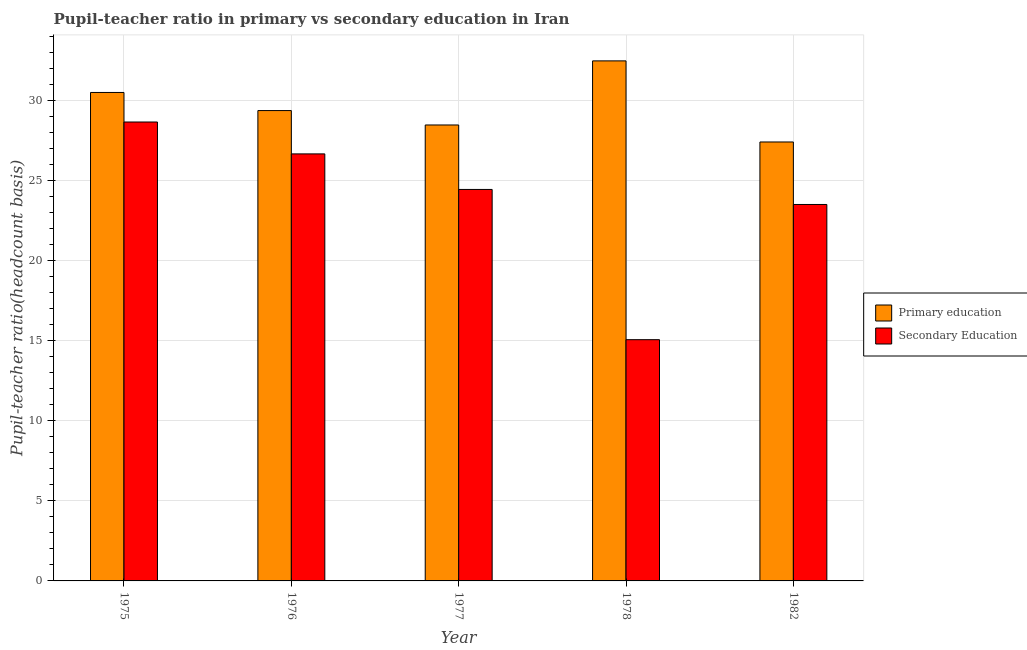How many different coloured bars are there?
Offer a terse response. 2. Are the number of bars per tick equal to the number of legend labels?
Your response must be concise. Yes. Are the number of bars on each tick of the X-axis equal?
Give a very brief answer. Yes. What is the label of the 4th group of bars from the left?
Your answer should be compact. 1978. What is the pupil teacher ratio on secondary education in 1976?
Ensure brevity in your answer.  26.67. Across all years, what is the maximum pupil-teacher ratio in primary education?
Offer a terse response. 32.48. Across all years, what is the minimum pupil-teacher ratio in primary education?
Offer a very short reply. 27.41. In which year was the pupil-teacher ratio in primary education maximum?
Provide a short and direct response. 1978. What is the total pupil-teacher ratio in primary education in the graph?
Give a very brief answer. 148.26. What is the difference between the pupil teacher ratio on secondary education in 1975 and that in 1977?
Your answer should be very brief. 4.21. What is the difference between the pupil teacher ratio on secondary education in 1978 and the pupil-teacher ratio in primary education in 1977?
Your answer should be compact. -9.38. What is the average pupil teacher ratio on secondary education per year?
Ensure brevity in your answer.  23.67. In the year 1976, what is the difference between the pupil-teacher ratio in primary education and pupil teacher ratio on secondary education?
Provide a succinct answer. 0. In how many years, is the pupil teacher ratio on secondary education greater than 11?
Offer a very short reply. 5. What is the ratio of the pupil-teacher ratio in primary education in 1977 to that in 1982?
Offer a terse response. 1.04. Is the pupil teacher ratio on secondary education in 1976 less than that in 1982?
Offer a terse response. No. What is the difference between the highest and the second highest pupil teacher ratio on secondary education?
Your answer should be compact. 1.99. What is the difference between the highest and the lowest pupil teacher ratio on secondary education?
Your answer should be very brief. 13.59. What does the 2nd bar from the left in 1977 represents?
Ensure brevity in your answer.  Secondary Education. How many bars are there?
Your answer should be very brief. 10. What is the difference between two consecutive major ticks on the Y-axis?
Your response must be concise. 5. Are the values on the major ticks of Y-axis written in scientific E-notation?
Provide a short and direct response. No. Does the graph contain any zero values?
Give a very brief answer. No. Does the graph contain grids?
Provide a succinct answer. Yes. Where does the legend appear in the graph?
Offer a very short reply. Center right. How many legend labels are there?
Your answer should be compact. 2. How are the legend labels stacked?
Make the answer very short. Vertical. What is the title of the graph?
Your response must be concise. Pupil-teacher ratio in primary vs secondary education in Iran. Does "Secondary school" appear as one of the legend labels in the graph?
Offer a very short reply. No. What is the label or title of the Y-axis?
Your answer should be very brief. Pupil-teacher ratio(headcount basis). What is the Pupil-teacher ratio(headcount basis) of Primary education in 1975?
Make the answer very short. 30.51. What is the Pupil-teacher ratio(headcount basis) in Secondary Education in 1975?
Keep it short and to the point. 28.66. What is the Pupil-teacher ratio(headcount basis) in Primary education in 1976?
Offer a very short reply. 29.38. What is the Pupil-teacher ratio(headcount basis) of Secondary Education in 1976?
Provide a succinct answer. 26.67. What is the Pupil-teacher ratio(headcount basis) in Primary education in 1977?
Keep it short and to the point. 28.48. What is the Pupil-teacher ratio(headcount basis) in Secondary Education in 1977?
Your response must be concise. 24.45. What is the Pupil-teacher ratio(headcount basis) in Primary education in 1978?
Offer a very short reply. 32.48. What is the Pupil-teacher ratio(headcount basis) of Secondary Education in 1978?
Ensure brevity in your answer.  15.07. What is the Pupil-teacher ratio(headcount basis) of Primary education in 1982?
Your response must be concise. 27.41. What is the Pupil-teacher ratio(headcount basis) of Secondary Education in 1982?
Offer a terse response. 23.51. Across all years, what is the maximum Pupil-teacher ratio(headcount basis) of Primary education?
Offer a very short reply. 32.48. Across all years, what is the maximum Pupil-teacher ratio(headcount basis) of Secondary Education?
Offer a terse response. 28.66. Across all years, what is the minimum Pupil-teacher ratio(headcount basis) of Primary education?
Keep it short and to the point. 27.41. Across all years, what is the minimum Pupil-teacher ratio(headcount basis) of Secondary Education?
Provide a succinct answer. 15.07. What is the total Pupil-teacher ratio(headcount basis) of Primary education in the graph?
Make the answer very short. 148.26. What is the total Pupil-teacher ratio(headcount basis) in Secondary Education in the graph?
Keep it short and to the point. 118.36. What is the difference between the Pupil-teacher ratio(headcount basis) in Primary education in 1975 and that in 1976?
Give a very brief answer. 1.13. What is the difference between the Pupil-teacher ratio(headcount basis) of Secondary Education in 1975 and that in 1976?
Give a very brief answer. 1.99. What is the difference between the Pupil-teacher ratio(headcount basis) in Primary education in 1975 and that in 1977?
Your response must be concise. 2.03. What is the difference between the Pupil-teacher ratio(headcount basis) of Secondary Education in 1975 and that in 1977?
Give a very brief answer. 4.21. What is the difference between the Pupil-teacher ratio(headcount basis) of Primary education in 1975 and that in 1978?
Ensure brevity in your answer.  -1.97. What is the difference between the Pupil-teacher ratio(headcount basis) in Secondary Education in 1975 and that in 1978?
Make the answer very short. 13.6. What is the difference between the Pupil-teacher ratio(headcount basis) in Primary education in 1975 and that in 1982?
Ensure brevity in your answer.  3.09. What is the difference between the Pupil-teacher ratio(headcount basis) of Secondary Education in 1975 and that in 1982?
Offer a very short reply. 5.15. What is the difference between the Pupil-teacher ratio(headcount basis) of Primary education in 1976 and that in 1977?
Ensure brevity in your answer.  0.9. What is the difference between the Pupil-teacher ratio(headcount basis) of Secondary Education in 1976 and that in 1977?
Offer a very short reply. 2.22. What is the difference between the Pupil-teacher ratio(headcount basis) of Primary education in 1976 and that in 1978?
Provide a short and direct response. -3.1. What is the difference between the Pupil-teacher ratio(headcount basis) in Secondary Education in 1976 and that in 1978?
Provide a succinct answer. 11.6. What is the difference between the Pupil-teacher ratio(headcount basis) of Primary education in 1976 and that in 1982?
Offer a very short reply. 1.96. What is the difference between the Pupil-teacher ratio(headcount basis) of Secondary Education in 1976 and that in 1982?
Your answer should be very brief. 3.16. What is the difference between the Pupil-teacher ratio(headcount basis) in Primary education in 1977 and that in 1978?
Provide a succinct answer. -4. What is the difference between the Pupil-teacher ratio(headcount basis) in Secondary Education in 1977 and that in 1978?
Ensure brevity in your answer.  9.38. What is the difference between the Pupil-teacher ratio(headcount basis) in Primary education in 1977 and that in 1982?
Keep it short and to the point. 1.06. What is the difference between the Pupil-teacher ratio(headcount basis) of Secondary Education in 1977 and that in 1982?
Ensure brevity in your answer.  0.94. What is the difference between the Pupil-teacher ratio(headcount basis) in Primary education in 1978 and that in 1982?
Offer a terse response. 5.07. What is the difference between the Pupil-teacher ratio(headcount basis) of Secondary Education in 1978 and that in 1982?
Give a very brief answer. -8.44. What is the difference between the Pupil-teacher ratio(headcount basis) of Primary education in 1975 and the Pupil-teacher ratio(headcount basis) of Secondary Education in 1976?
Give a very brief answer. 3.84. What is the difference between the Pupil-teacher ratio(headcount basis) of Primary education in 1975 and the Pupil-teacher ratio(headcount basis) of Secondary Education in 1977?
Give a very brief answer. 6.06. What is the difference between the Pupil-teacher ratio(headcount basis) in Primary education in 1975 and the Pupil-teacher ratio(headcount basis) in Secondary Education in 1978?
Your answer should be very brief. 15.44. What is the difference between the Pupil-teacher ratio(headcount basis) of Primary education in 1975 and the Pupil-teacher ratio(headcount basis) of Secondary Education in 1982?
Your answer should be very brief. 7. What is the difference between the Pupil-teacher ratio(headcount basis) in Primary education in 1976 and the Pupil-teacher ratio(headcount basis) in Secondary Education in 1977?
Your answer should be compact. 4.93. What is the difference between the Pupil-teacher ratio(headcount basis) in Primary education in 1976 and the Pupil-teacher ratio(headcount basis) in Secondary Education in 1978?
Your response must be concise. 14.31. What is the difference between the Pupil-teacher ratio(headcount basis) in Primary education in 1976 and the Pupil-teacher ratio(headcount basis) in Secondary Education in 1982?
Keep it short and to the point. 5.87. What is the difference between the Pupil-teacher ratio(headcount basis) of Primary education in 1977 and the Pupil-teacher ratio(headcount basis) of Secondary Education in 1978?
Your response must be concise. 13.41. What is the difference between the Pupil-teacher ratio(headcount basis) of Primary education in 1977 and the Pupil-teacher ratio(headcount basis) of Secondary Education in 1982?
Your response must be concise. 4.97. What is the difference between the Pupil-teacher ratio(headcount basis) in Primary education in 1978 and the Pupil-teacher ratio(headcount basis) in Secondary Education in 1982?
Offer a very short reply. 8.97. What is the average Pupil-teacher ratio(headcount basis) in Primary education per year?
Ensure brevity in your answer.  29.65. What is the average Pupil-teacher ratio(headcount basis) of Secondary Education per year?
Your answer should be compact. 23.67. In the year 1975, what is the difference between the Pupil-teacher ratio(headcount basis) of Primary education and Pupil-teacher ratio(headcount basis) of Secondary Education?
Keep it short and to the point. 1.85. In the year 1976, what is the difference between the Pupil-teacher ratio(headcount basis) of Primary education and Pupil-teacher ratio(headcount basis) of Secondary Education?
Ensure brevity in your answer.  2.71. In the year 1977, what is the difference between the Pupil-teacher ratio(headcount basis) of Primary education and Pupil-teacher ratio(headcount basis) of Secondary Education?
Provide a succinct answer. 4.03. In the year 1978, what is the difference between the Pupil-teacher ratio(headcount basis) of Primary education and Pupil-teacher ratio(headcount basis) of Secondary Education?
Offer a terse response. 17.41. In the year 1982, what is the difference between the Pupil-teacher ratio(headcount basis) in Primary education and Pupil-teacher ratio(headcount basis) in Secondary Education?
Provide a short and direct response. 3.9. What is the ratio of the Pupil-teacher ratio(headcount basis) of Primary education in 1975 to that in 1976?
Make the answer very short. 1.04. What is the ratio of the Pupil-teacher ratio(headcount basis) in Secondary Education in 1975 to that in 1976?
Ensure brevity in your answer.  1.07. What is the ratio of the Pupil-teacher ratio(headcount basis) in Primary education in 1975 to that in 1977?
Give a very brief answer. 1.07. What is the ratio of the Pupil-teacher ratio(headcount basis) in Secondary Education in 1975 to that in 1977?
Provide a short and direct response. 1.17. What is the ratio of the Pupil-teacher ratio(headcount basis) of Primary education in 1975 to that in 1978?
Make the answer very short. 0.94. What is the ratio of the Pupil-teacher ratio(headcount basis) of Secondary Education in 1975 to that in 1978?
Provide a short and direct response. 1.9. What is the ratio of the Pupil-teacher ratio(headcount basis) of Primary education in 1975 to that in 1982?
Offer a terse response. 1.11. What is the ratio of the Pupil-teacher ratio(headcount basis) in Secondary Education in 1975 to that in 1982?
Your answer should be compact. 1.22. What is the ratio of the Pupil-teacher ratio(headcount basis) of Primary education in 1976 to that in 1977?
Your response must be concise. 1.03. What is the ratio of the Pupil-teacher ratio(headcount basis) in Secondary Education in 1976 to that in 1977?
Give a very brief answer. 1.09. What is the ratio of the Pupil-teacher ratio(headcount basis) in Primary education in 1976 to that in 1978?
Give a very brief answer. 0.9. What is the ratio of the Pupil-teacher ratio(headcount basis) in Secondary Education in 1976 to that in 1978?
Offer a very short reply. 1.77. What is the ratio of the Pupil-teacher ratio(headcount basis) in Primary education in 1976 to that in 1982?
Make the answer very short. 1.07. What is the ratio of the Pupil-teacher ratio(headcount basis) in Secondary Education in 1976 to that in 1982?
Give a very brief answer. 1.13. What is the ratio of the Pupil-teacher ratio(headcount basis) in Primary education in 1977 to that in 1978?
Provide a short and direct response. 0.88. What is the ratio of the Pupil-teacher ratio(headcount basis) in Secondary Education in 1977 to that in 1978?
Offer a terse response. 1.62. What is the ratio of the Pupil-teacher ratio(headcount basis) in Primary education in 1977 to that in 1982?
Your answer should be very brief. 1.04. What is the ratio of the Pupil-teacher ratio(headcount basis) of Secondary Education in 1977 to that in 1982?
Your answer should be compact. 1.04. What is the ratio of the Pupil-teacher ratio(headcount basis) in Primary education in 1978 to that in 1982?
Your response must be concise. 1.18. What is the ratio of the Pupil-teacher ratio(headcount basis) of Secondary Education in 1978 to that in 1982?
Your response must be concise. 0.64. What is the difference between the highest and the second highest Pupil-teacher ratio(headcount basis) of Primary education?
Ensure brevity in your answer.  1.97. What is the difference between the highest and the second highest Pupil-teacher ratio(headcount basis) of Secondary Education?
Provide a short and direct response. 1.99. What is the difference between the highest and the lowest Pupil-teacher ratio(headcount basis) of Primary education?
Provide a succinct answer. 5.07. What is the difference between the highest and the lowest Pupil-teacher ratio(headcount basis) of Secondary Education?
Your response must be concise. 13.6. 